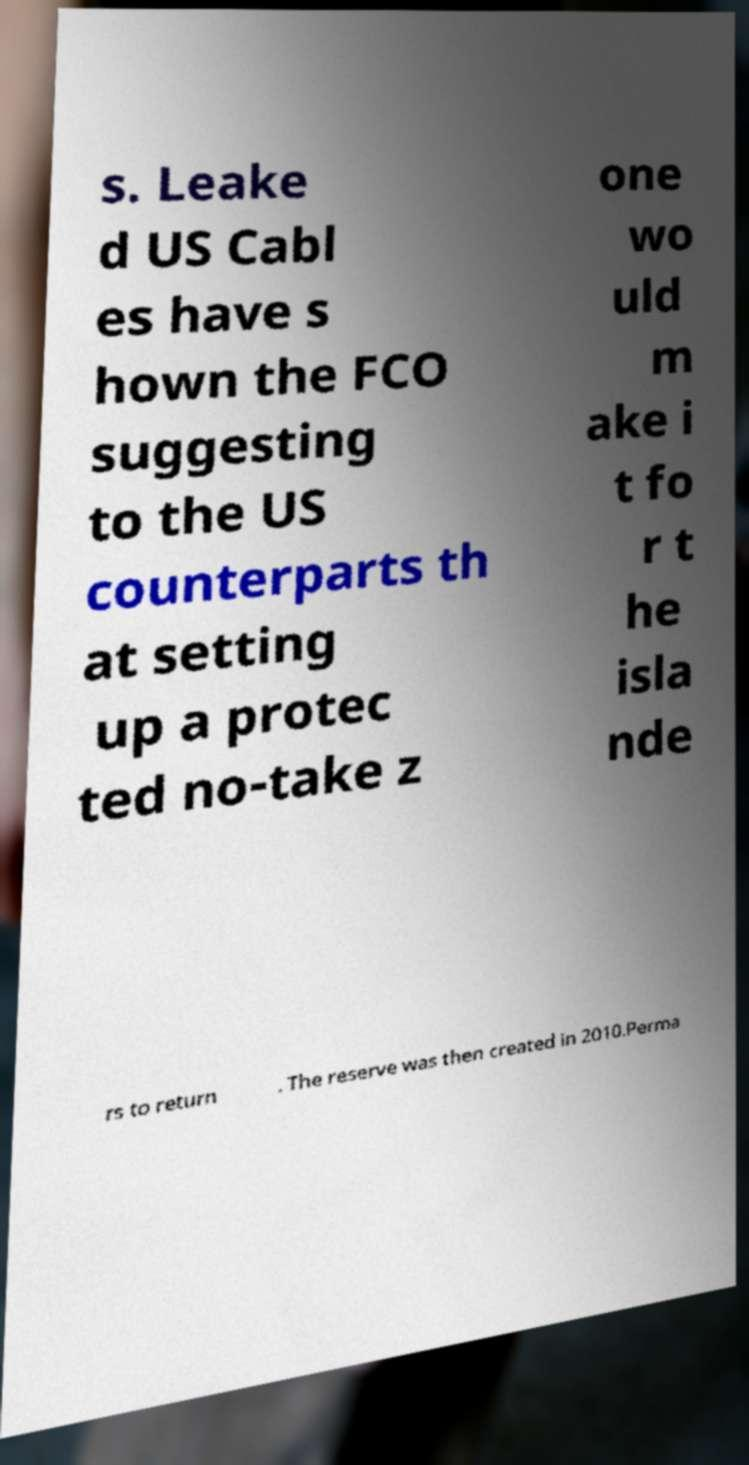Can you accurately transcribe the text from the provided image for me? s. Leake d US Cabl es have s hown the FCO suggesting to the US counterparts th at setting up a protec ted no-take z one wo uld m ake i t fo r t he isla nde rs to return . The reserve was then created in 2010.Perma 